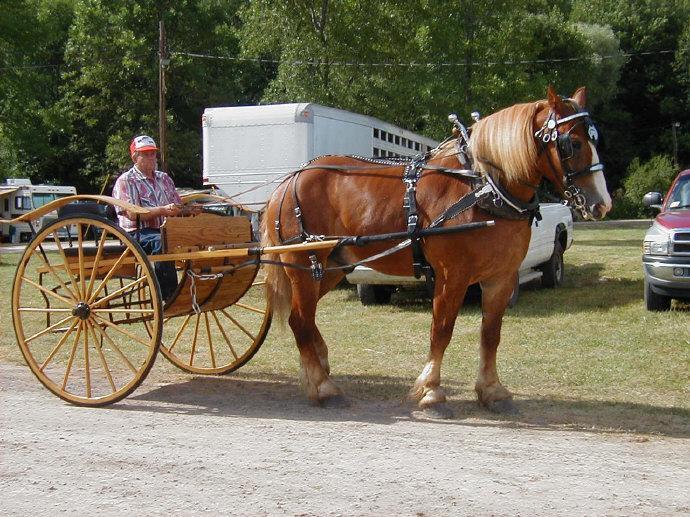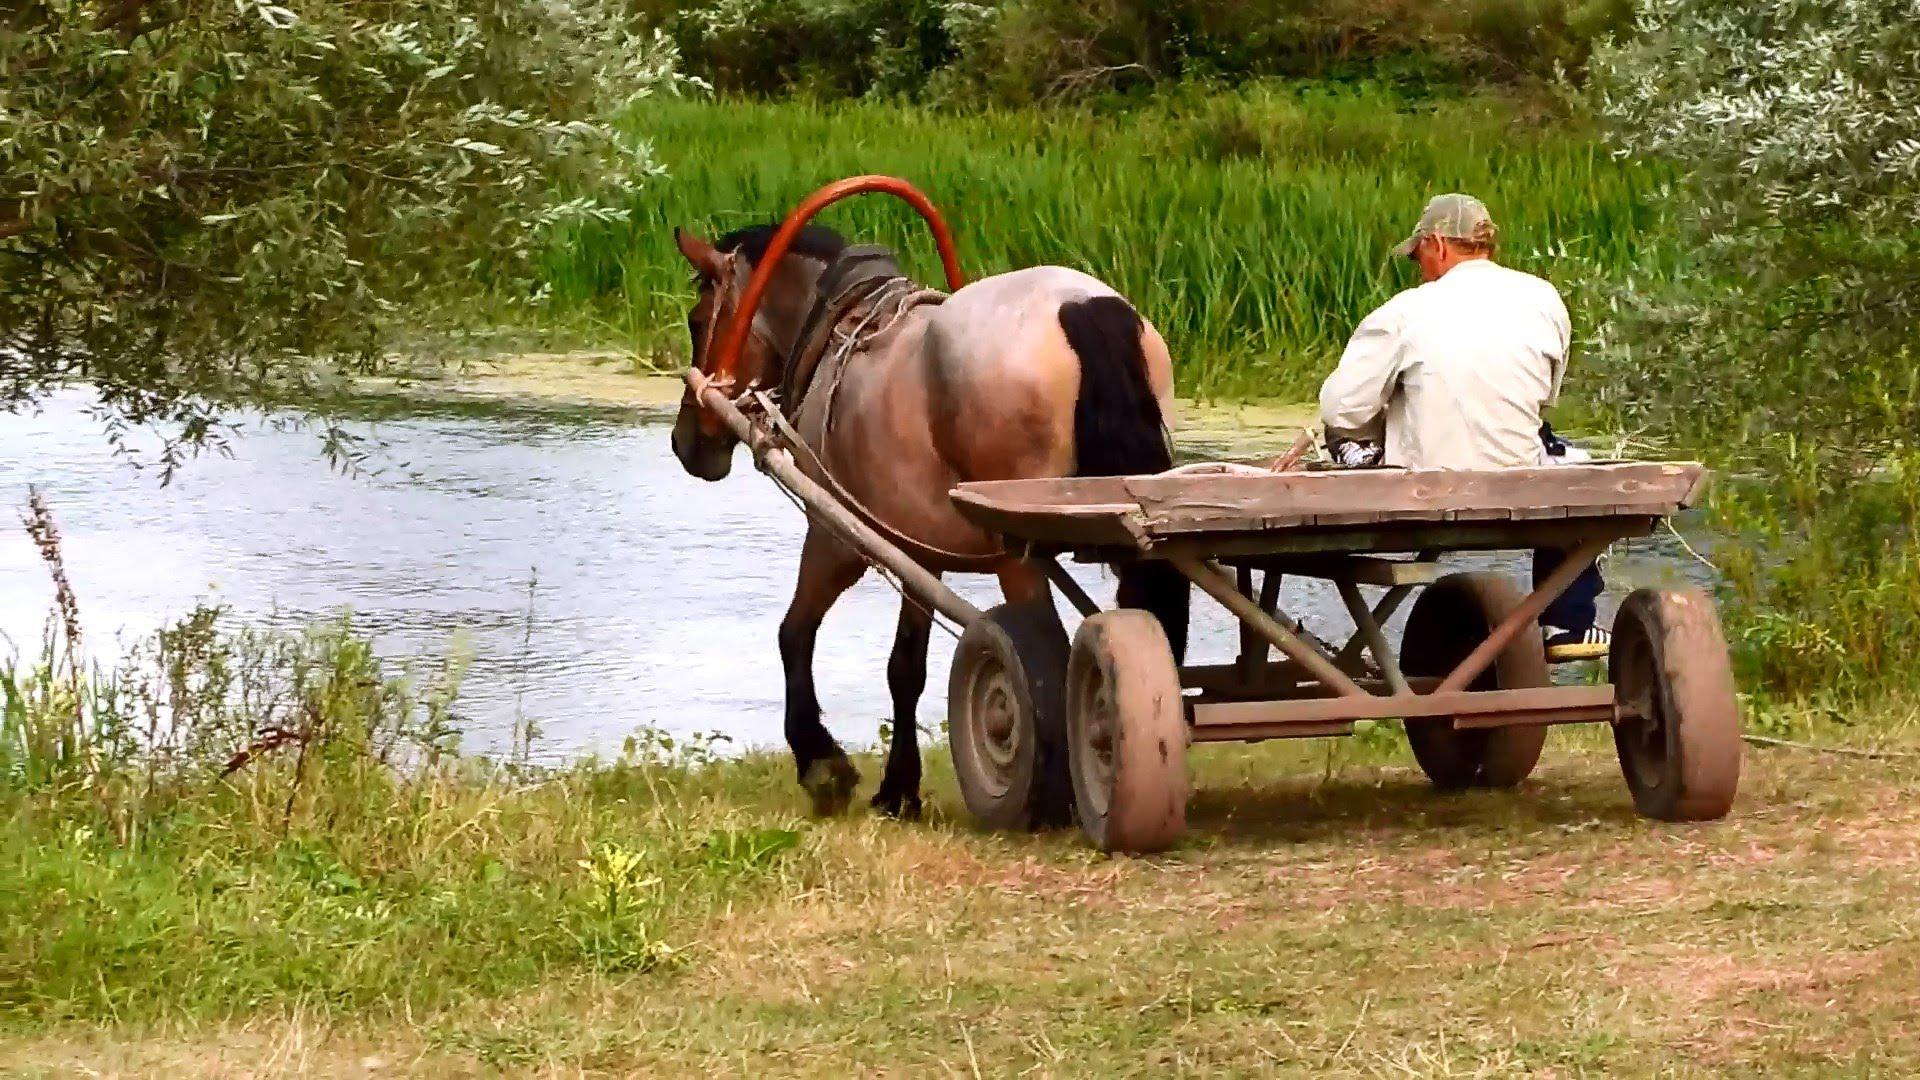The first image is the image on the left, the second image is the image on the right. Considering the images on both sides, is "At least one horse is white." valid? Answer yes or no. No. 